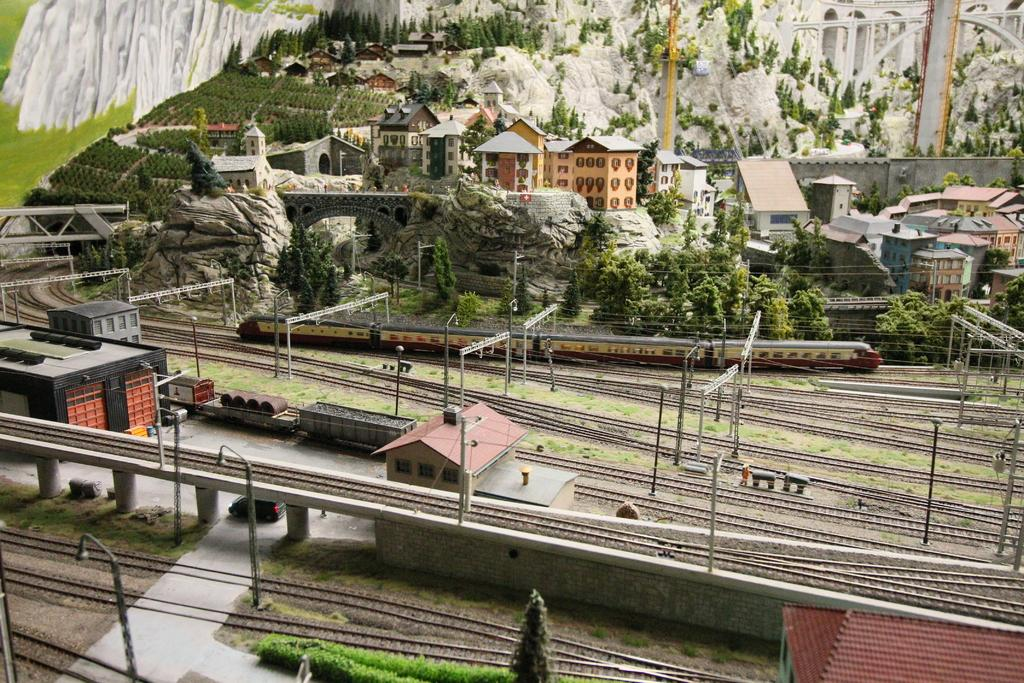What type of transportation infrastructure is visible in the image? There are railway tracks in the image. What structures are present alongside the railway tracks? There are poles in the image. What type of vegetation can be seen in the image? There are plants and trees in the image. What mode of transportation can be seen in the image? There is a train in the image. What type of buildings are visible in the image? There are houses in the image. What geographical feature is visible in the background of the image? There is a mountain in the background of the image. What verse is being recited by the train in the image? There is no indication in the image that the train is reciting a verse. What base is the mountain in the image built upon? The mountain is a natural geographical feature and not built upon a base. 